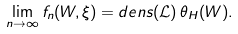Convert formula to latex. <formula><loc_0><loc_0><loc_500><loc_500>\lim _ { n \to \infty } f _ { n } ( W , \xi ) = d e n s ( \mathcal { L } ) \, \theta _ { H } ( W ) .</formula> 